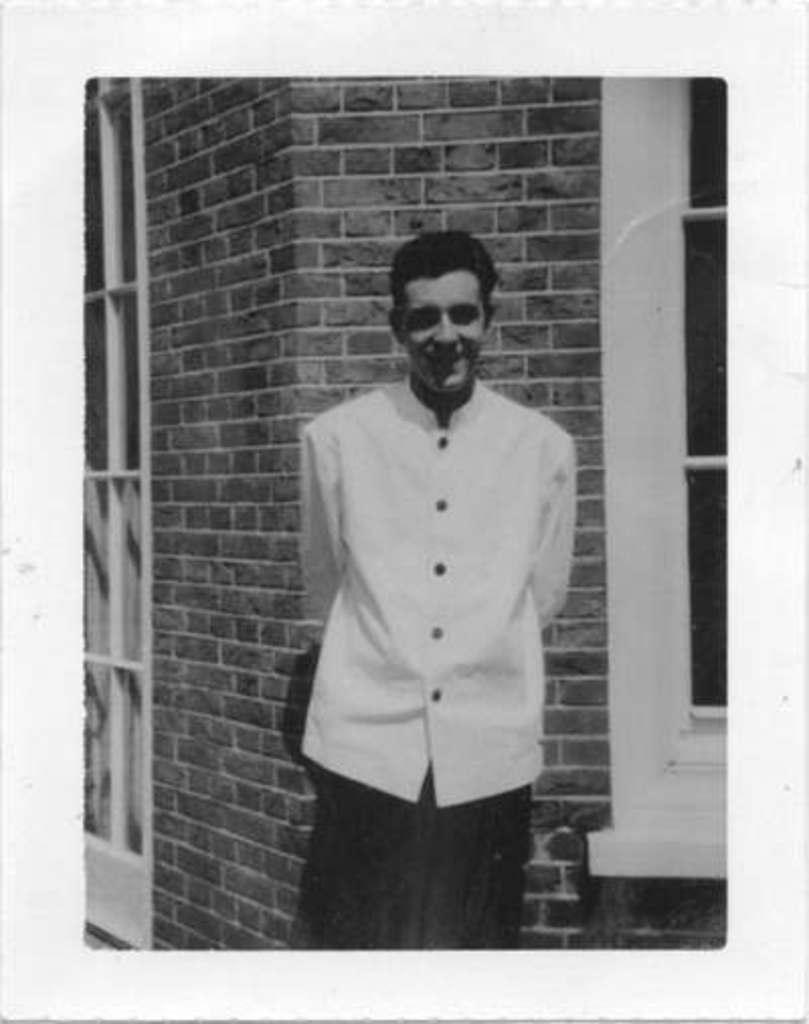What is the main subject of the image? There is a person standing in the image. What can be seen in the background of the image? There is a wall in the background of the image. What features are present on the wall? There is a window and a door in the wall. How does the person in the image solve the riddle presented on the wall? There is no riddle present on the wall in the image, so it cannot be solved by the person in the image. 